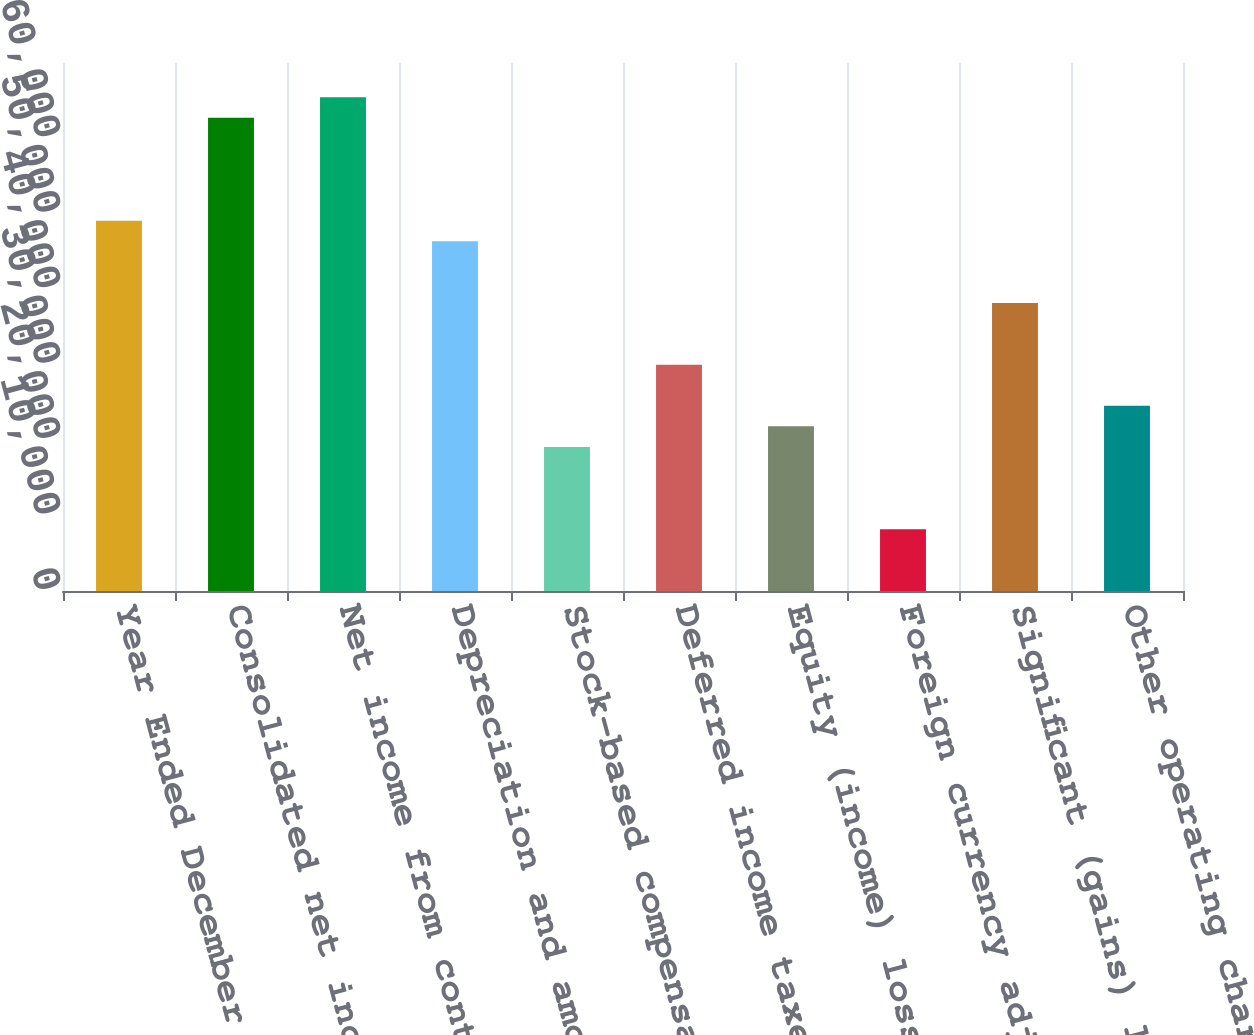<chart> <loc_0><loc_0><loc_500><loc_500><bar_chart><fcel>Year Ended December 31<fcel>Consolidated net income<fcel>Net income from continuing<fcel>Depreciation and amortization<fcel>Stock-based compensation<fcel>Deferred income taxes<fcel>Equity (income) loss - net of<fcel>Foreign currency adjustments<fcel>Significant (gains) losses on<fcel>Other operating charges<nl><fcel>49101<fcel>62738.5<fcel>65466<fcel>46373.5<fcel>19098.5<fcel>30008.5<fcel>21826<fcel>8188.5<fcel>38191<fcel>24553.5<nl></chart> 